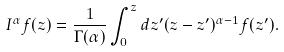<formula> <loc_0><loc_0><loc_500><loc_500>I ^ { \alpha } f ( z ) = \frac { 1 } { \Gamma ( \alpha ) } \int _ { 0 } ^ { z } d z ^ { \prime } ( z - z ^ { \prime } ) ^ { \alpha - 1 } f ( z ^ { \prime } ) .</formula> 